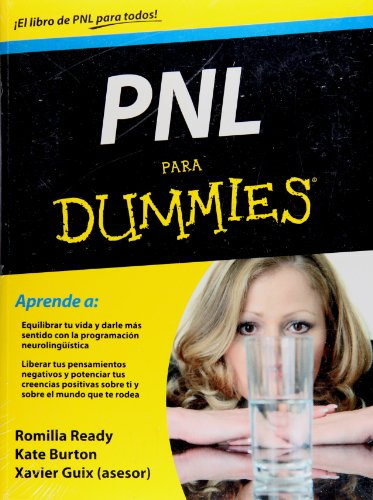Can you tell me something about neurolinguistic programming that this book might cover? Neurolinguistic programming, or NLP, is a psychological approach that involves analyzing strategies used by successful individuals and applying them to reach personal goals. It focuses on language, communication, and personal development, and this book likely provides an accessible introduction to these concepts for self-improvement enthusiasts. 